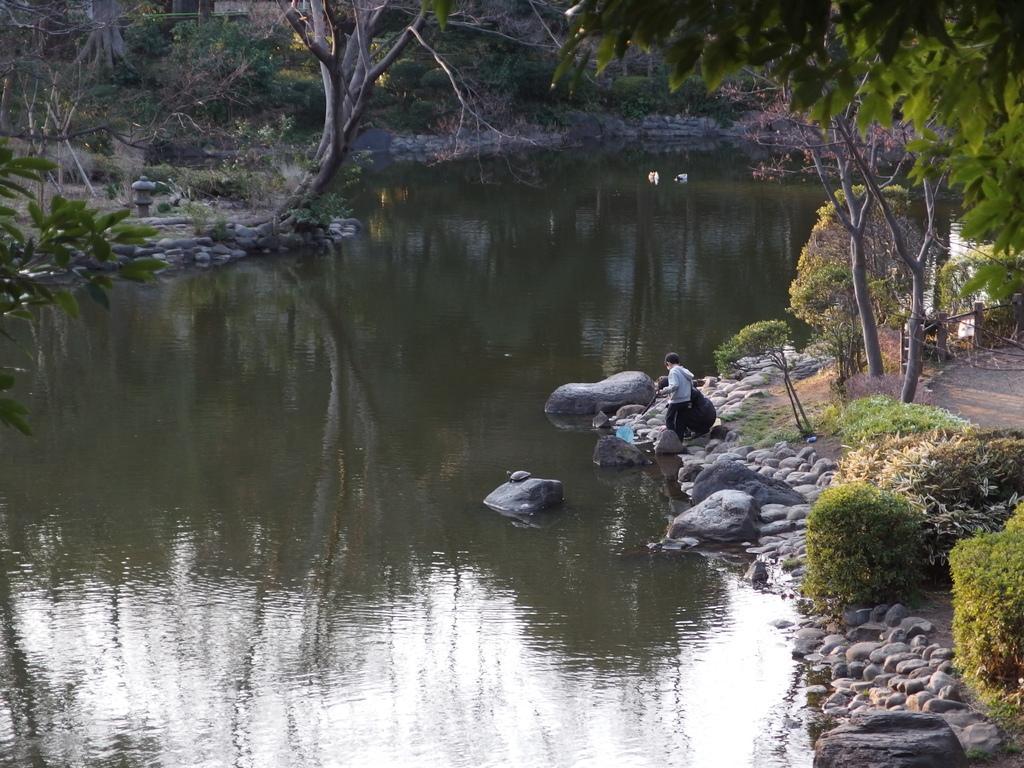Could you give a brief overview of what you see in this image? In this image we can see water, trees, plants and rocks. On the right side of the water, there is a man standing on the rock. 